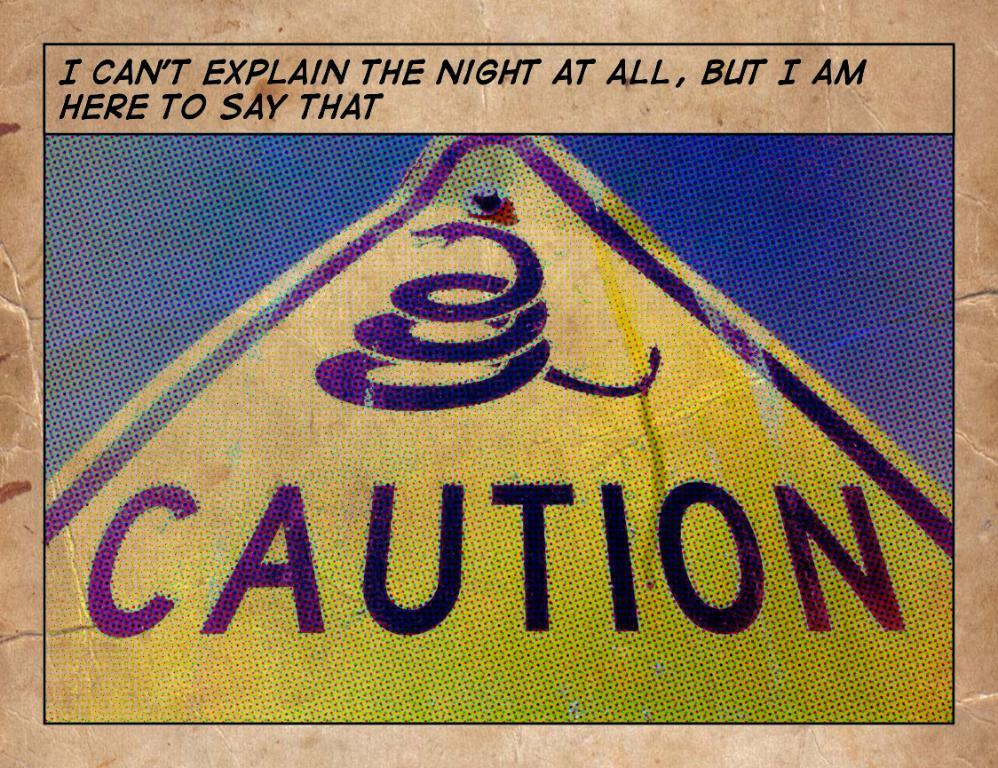<image>
Present a compact description of the photo's key features. a yellow caution triangle sign with snake logo 